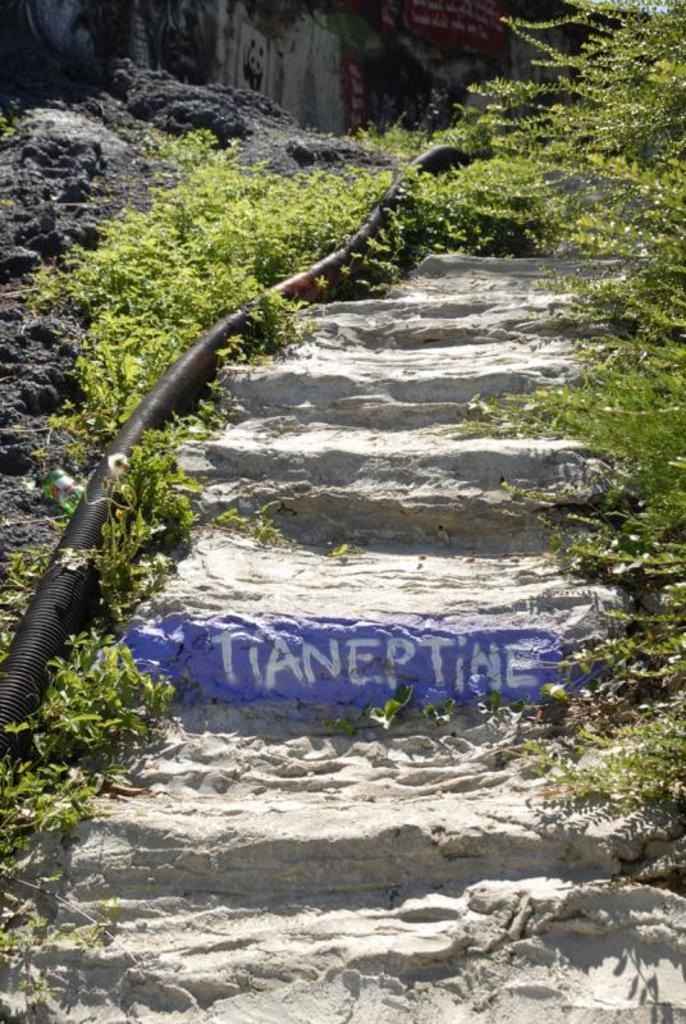What type of living organisms can be seen in the image? Plants can be seen in the image. What architectural feature is present in the image? There are steps in the image. What type of object can be seen that is not a living organism or architectural feature? There is a black color pipe in the image. What type of shock can be seen in the image? There is no shock present in the image. What type of board is visible in the image? There is no board present in the image. 